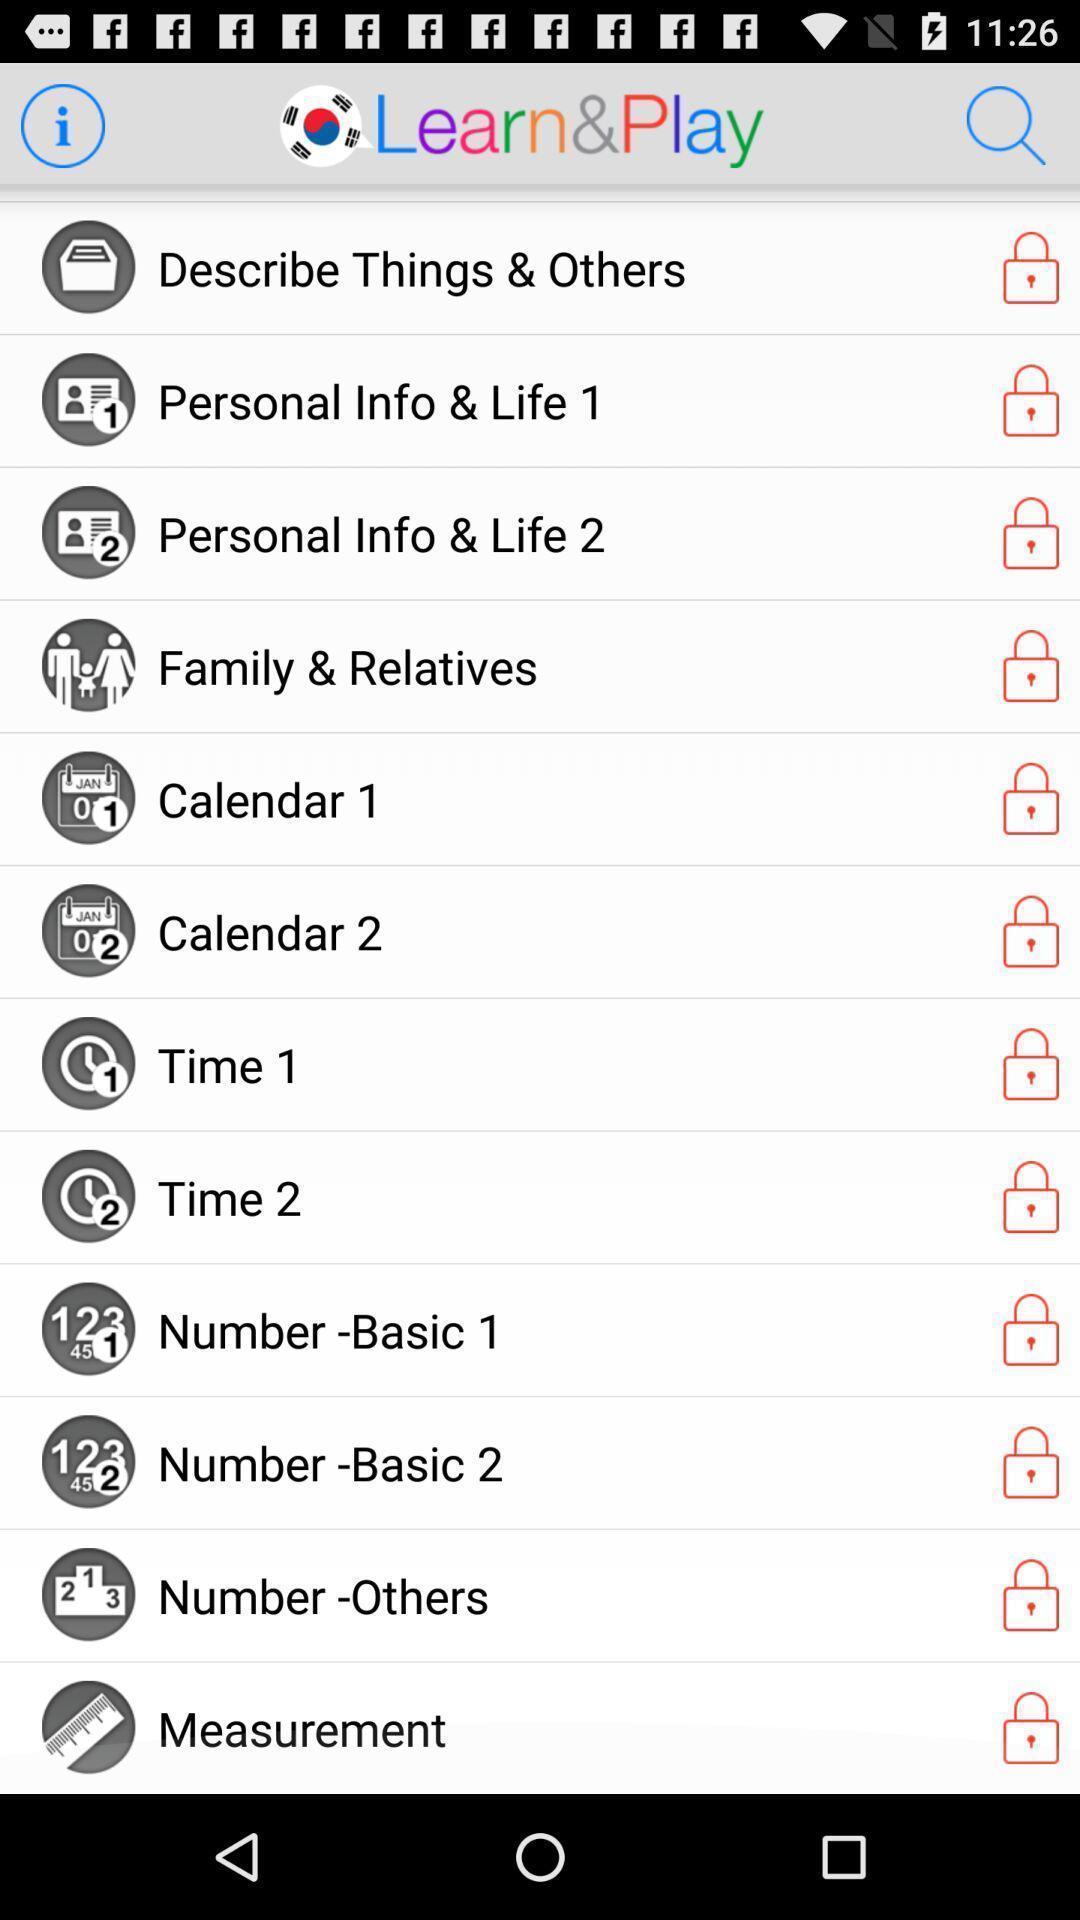Tell me about the visual elements in this screen capture. Screen shows a learning app. 